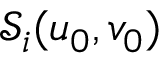<formula> <loc_0><loc_0><loc_500><loc_500>\mathcal { S } _ { i } ( u _ { 0 } , v _ { 0 } )</formula> 